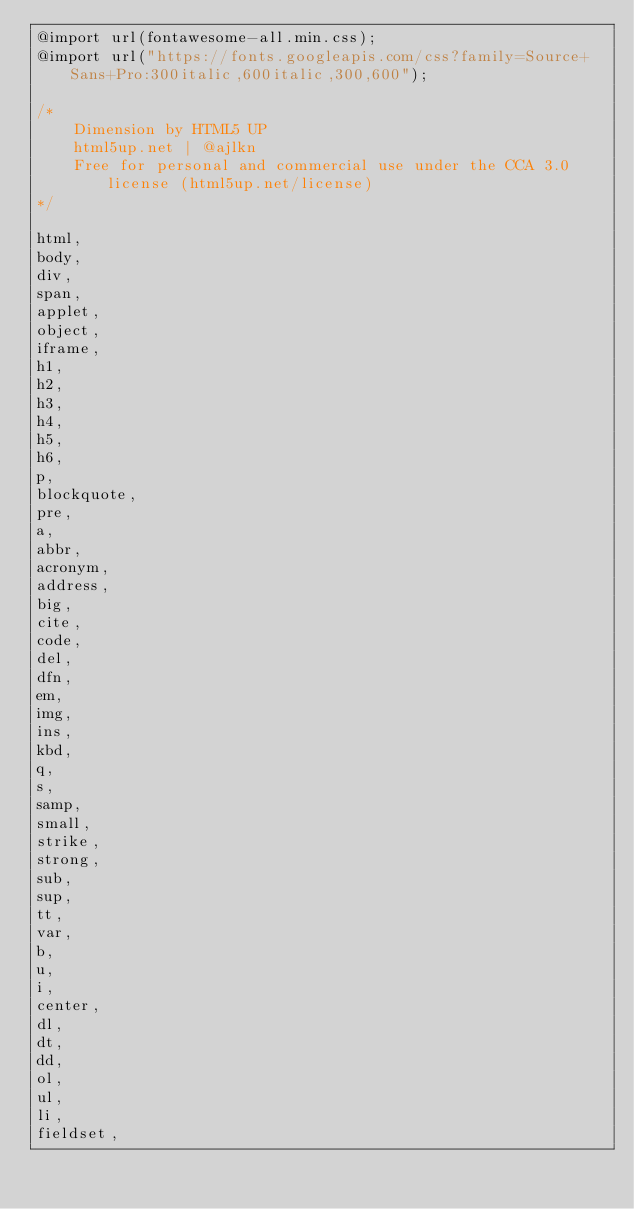<code> <loc_0><loc_0><loc_500><loc_500><_CSS_>@import url(fontawesome-all.min.css);
@import url("https://fonts.googleapis.com/css?family=Source+Sans+Pro:300italic,600italic,300,600");

/*
    Dimension by HTML5 UP
    html5up.net | @ajlkn
    Free for personal and commercial use under the CCA 3.0 license (html5up.net/license)
*/

html,
body,
div,
span,
applet,
object,
iframe,
h1,
h2,
h3,
h4,
h5,
h6,
p,
blockquote,
pre,
a,
abbr,
acronym,
address,
big,
cite,
code,
del,
dfn,
em,
img,
ins,
kbd,
q,
s,
samp,
small,
strike,
strong,
sub,
sup,
tt,
var,
b,
u,
i,
center,
dl,
dt,
dd,
ol,
ul,
li,
fieldset,</code> 